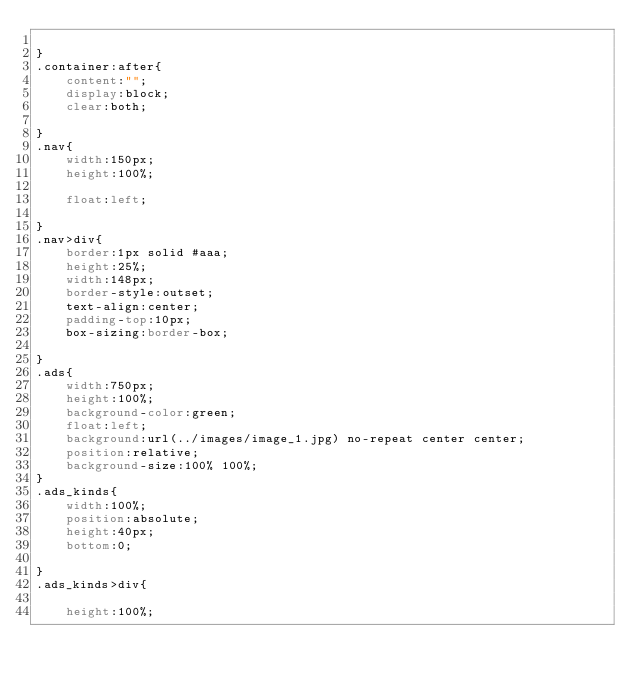Convert code to text. <code><loc_0><loc_0><loc_500><loc_500><_CSS_>	
}
.container:after{
	content:"";
	display:block;
	clear:both;
	
}
.nav{
	width:150px;
	height:100%;
	
	float:left;
	
}
.nav>div{
	border:1px solid #aaa;
	height:25%;
	width:148px;
	border-style:outset;
	text-align:center;
	padding-top:10px;
	box-sizing:border-box;

}
.ads{
	width:750px;
	height:100%;
	background-color:green;
	float:left;
	background:url(../images/image_1.jpg) no-repeat center center;
	position:relative;
	background-size:100% 100%;
}
.ads_kinds{
	width:100%;
	position:absolute;
	height:40px;
	bottom:0;
	
}
.ads_kinds>div{
	
	height:100%;</code> 